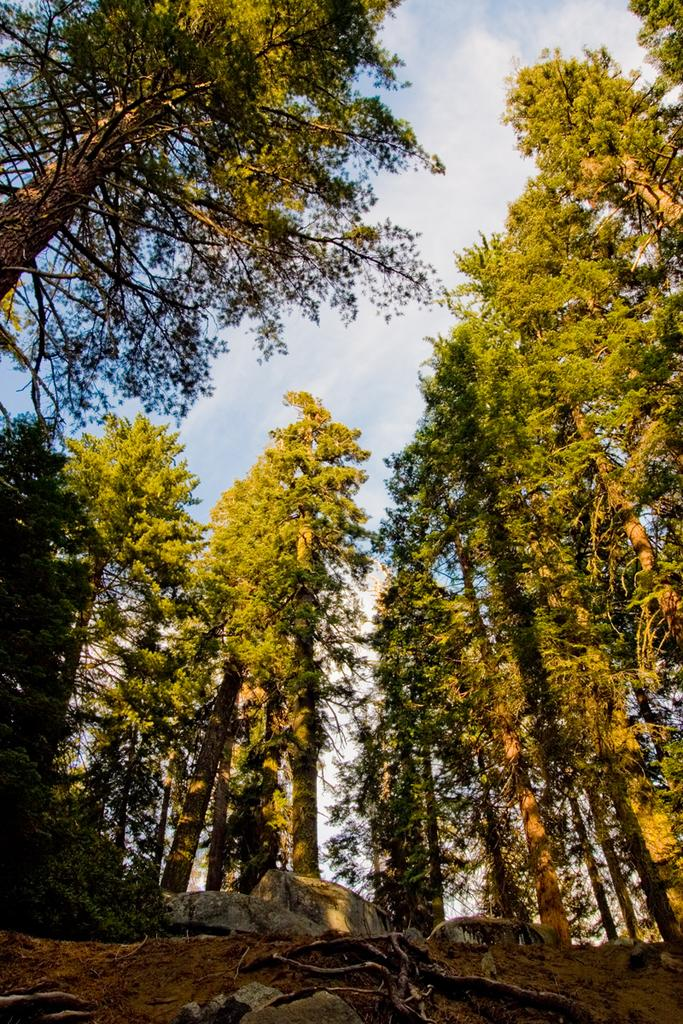What type of natural elements can be seen in the image? There are stones and trees visible in the image. What can be seen in the sky in the image? There are clouds visible in the image. What part of the natural environment is visible in the image? The sky is visible in the image. What is the weight of the bead hanging from the tree in the image? There is no bead hanging from the tree in the image. Is there a cave visible in the image? There is no cave present in the image. 